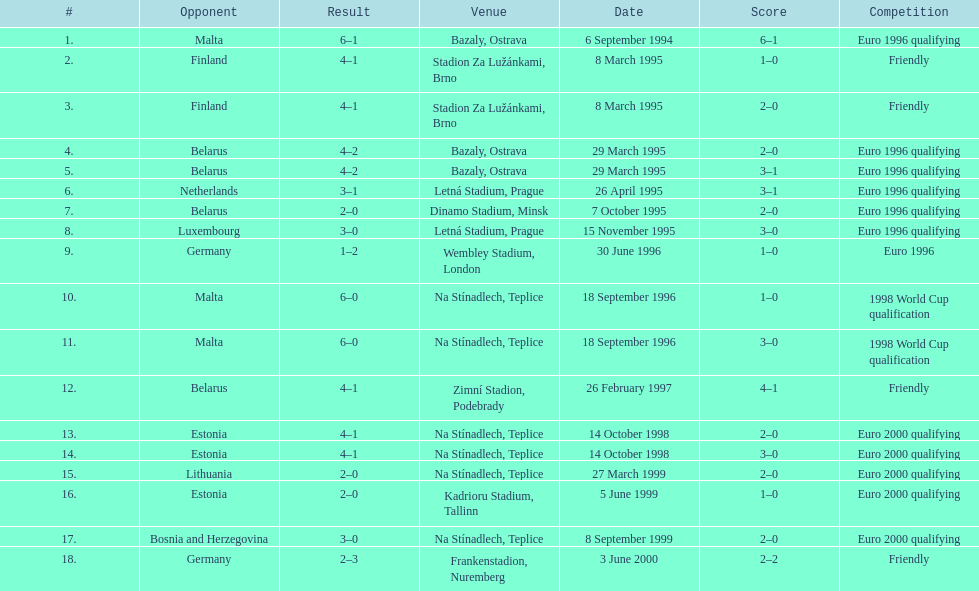How many total games took place in 1999? 3. 